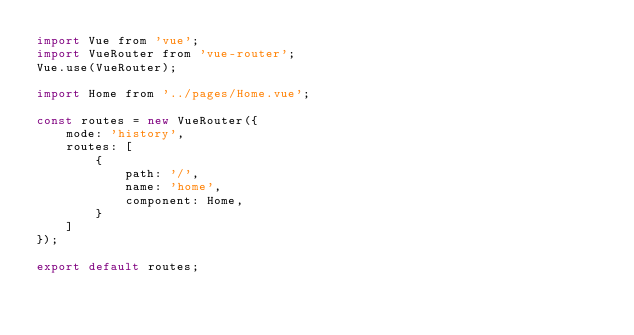<code> <loc_0><loc_0><loc_500><loc_500><_JavaScript_>import Vue from 'vue';
import VueRouter from 'vue-router';
Vue.use(VueRouter);

import Home from '../pages/Home.vue';

const routes = new VueRouter({
    mode: 'history',
    routes: [
        {
            path: '/',
            name: 'home',
            component: Home,
        }
    ]
});

export default routes;</code> 